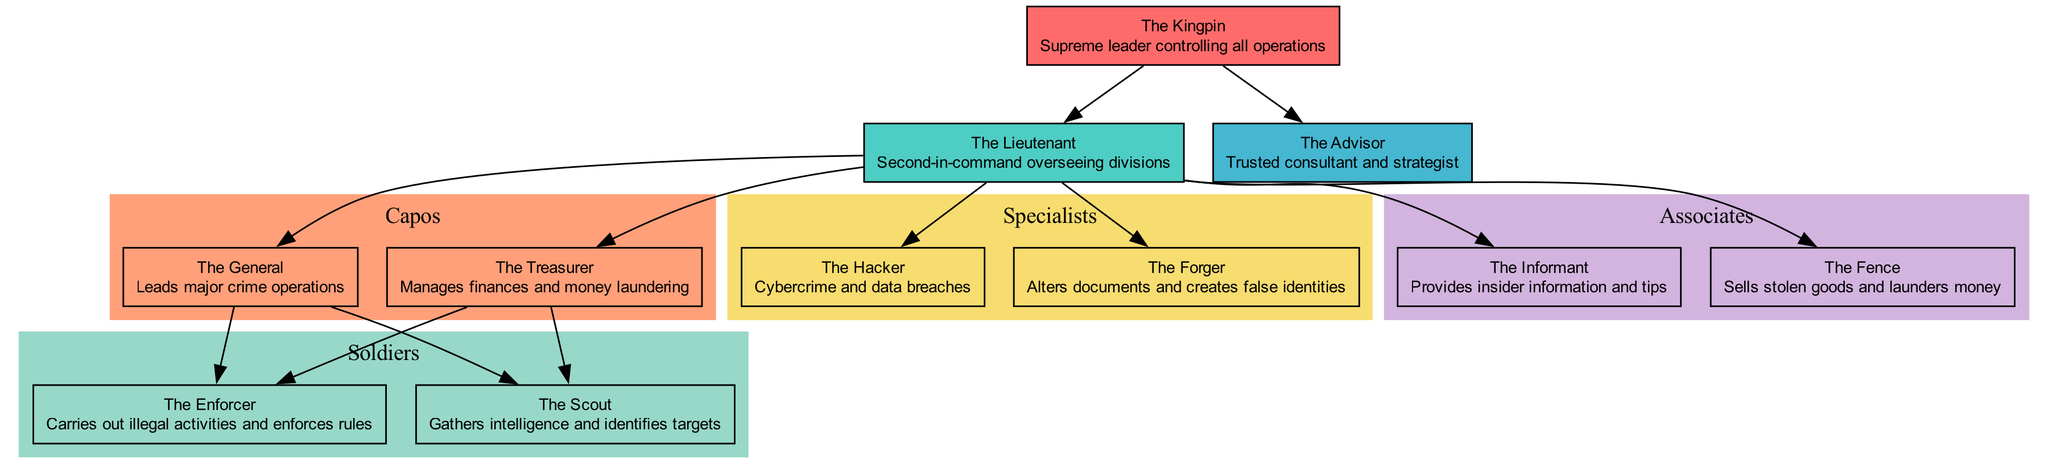What is the role of the 'Capos'? The diagram defines 'Capos' as leads of major crime operations, which is indicated in the node description.
Answer: Leads major crime operations Who directly reports to the 'Boss'? The diagram shows two positions, 'Underboss' and 'Consigliere', that have edges leading to them directly from the 'Boss'.
Answer: Underboss, Consigliere How many soldiers are in the organization? By examining the 'Soldiers' section of the diagram, we see two roles listed: 'The Enforcer' and 'The Scout', indicating a total of two soldiers.
Answer: 2 Which role is responsible for managing finances? Within the 'Capos' section of the diagram, 'The Treasurer' is defined as the individual managing finances and money laundering.
Answer: The Treasurer What group does 'The Scout' belong to? The diagram places 'The Scout' under the 'Soldiers' category, as can be seen in the designated section for soldiers.
Answer: Soldiers How many associates are listed in the diagram? By checking the 'Associates' section, we find that there are two roles specified: 'The Informant' and 'The Fence', confirming a total of two associates.
Answer: 2 Who is responsible for cybercrime? The diagram connects 'The Hacker' to the 'Specialists' group, indicating that this role is assigned to handle cybercrime and data breaches.
Answer: The Hacker Which two roles are supervised by the 'Underboss'? Referring to the edges in the diagram, the 'Underboss' connects to the 'Capos', 'Specialists', and 'Associates', however since the question specifies two roles, we can choose any of them. Choosing 'The General' and 'The Treasurer' as one example suffices.
Answer: The General, The Treasurer What does the 'Consigliere' advise on? According to the diagram, the 'Consigliere' is a trusted consultant and strategist, which is explicitly mentioned in its role description within the node.
Answer: Trusted consultant and strategist 